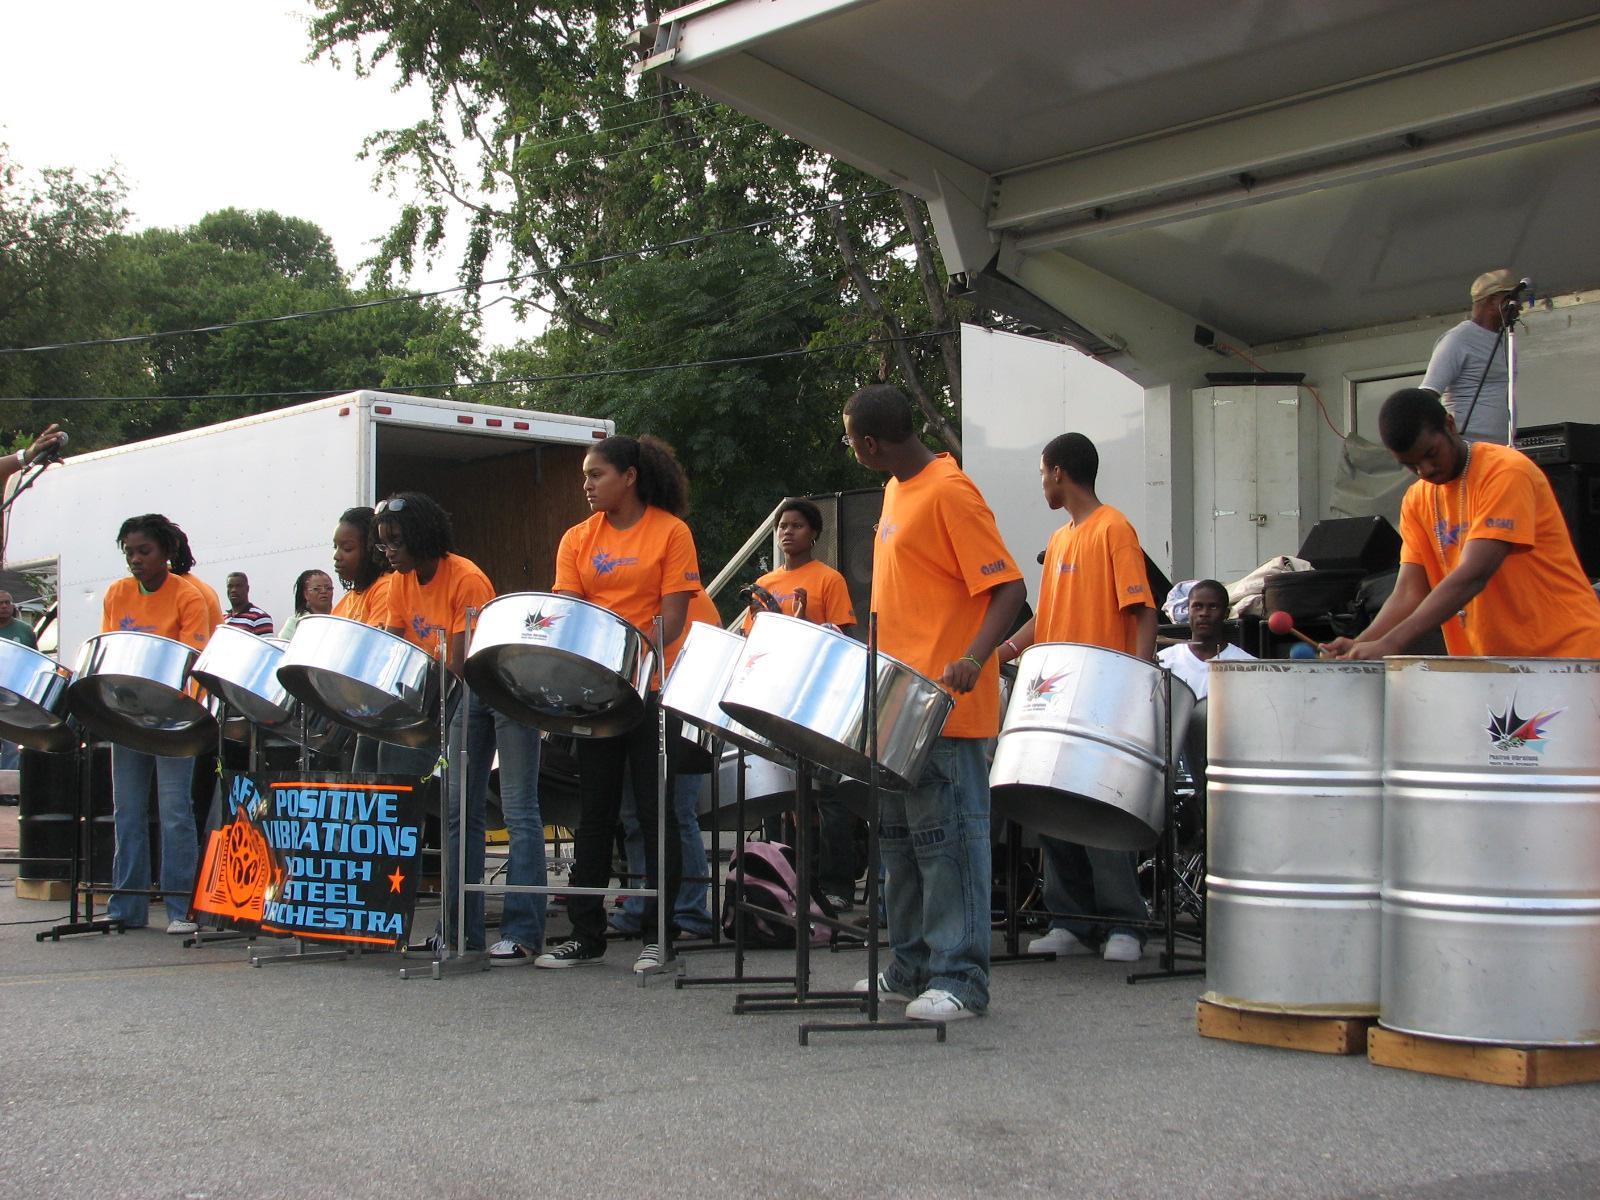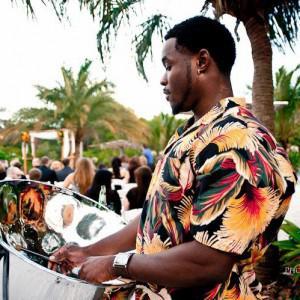The first image is the image on the left, the second image is the image on the right. For the images shown, is this caption "The drummer in the image on the right is wearing a blue and white shirt." true? Answer yes or no. No. The first image is the image on the left, the second image is the image on the right. Considering the images on both sides, is "One man with long braids wearing a blue hawaiian shirt is playing stainless steel bowl-shaped drums in the right image." valid? Answer yes or no. No. 